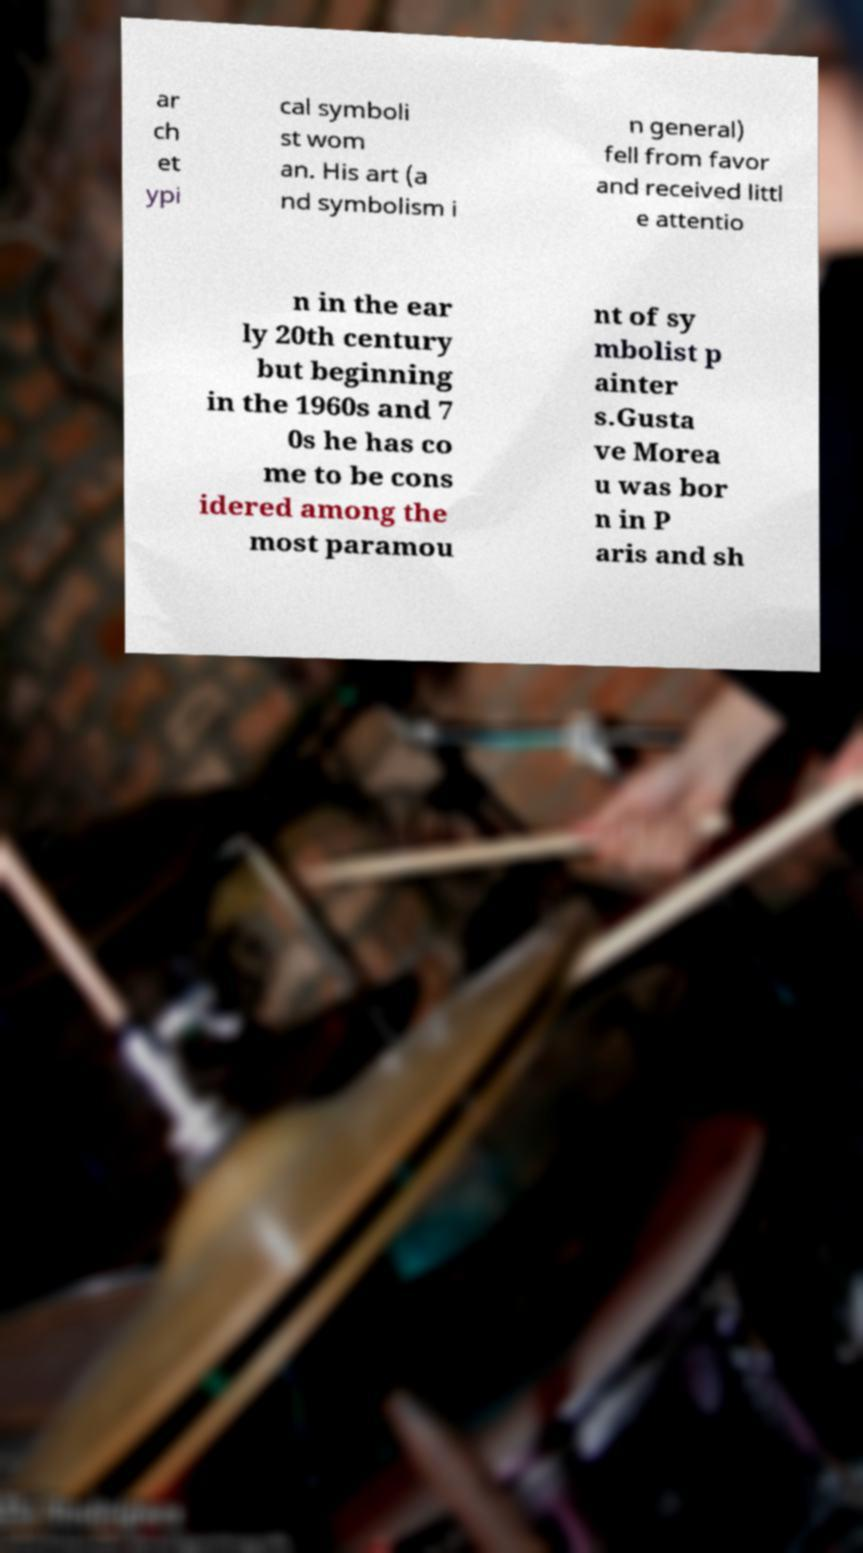Could you assist in decoding the text presented in this image and type it out clearly? ar ch et ypi cal symboli st wom an. His art (a nd symbolism i n general) fell from favor and received littl e attentio n in the ear ly 20th century but beginning in the 1960s and 7 0s he has co me to be cons idered among the most paramou nt of sy mbolist p ainter s.Gusta ve Morea u was bor n in P aris and sh 